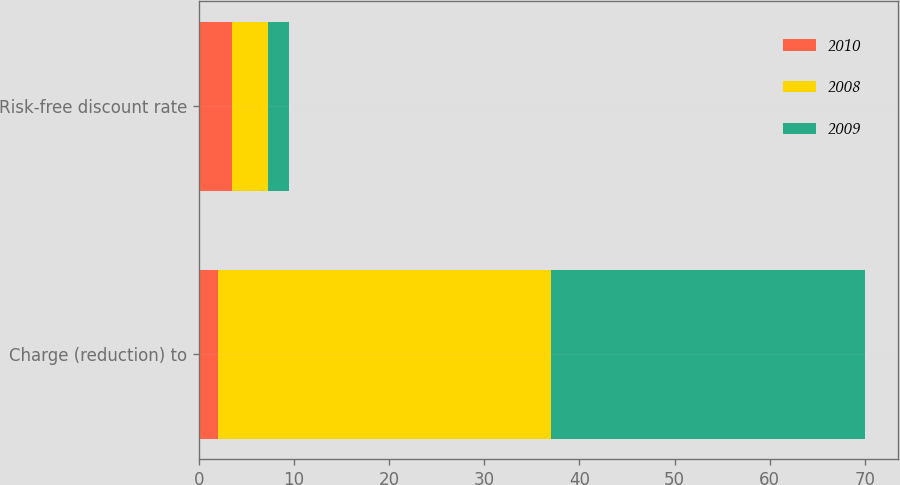Convert chart. <chart><loc_0><loc_0><loc_500><loc_500><stacked_bar_chart><ecel><fcel>Charge (reduction) to<fcel>Risk-free discount rate<nl><fcel>2010<fcel>2<fcel>3.5<nl><fcel>2008<fcel>35<fcel>3.75<nl><fcel>2009<fcel>33<fcel>2.25<nl></chart> 